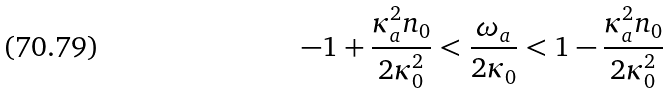Convert formula to latex. <formula><loc_0><loc_0><loc_500><loc_500>- 1 + \frac { \kappa _ { a } ^ { 2 } n _ { 0 } } { 2 \kappa _ { 0 } ^ { 2 } } < \frac { \omega _ { a } } { 2 \kappa _ { 0 } } < 1 - \frac { \kappa _ { a } ^ { 2 } n _ { 0 } } { 2 \kappa _ { 0 } ^ { 2 } }</formula> 